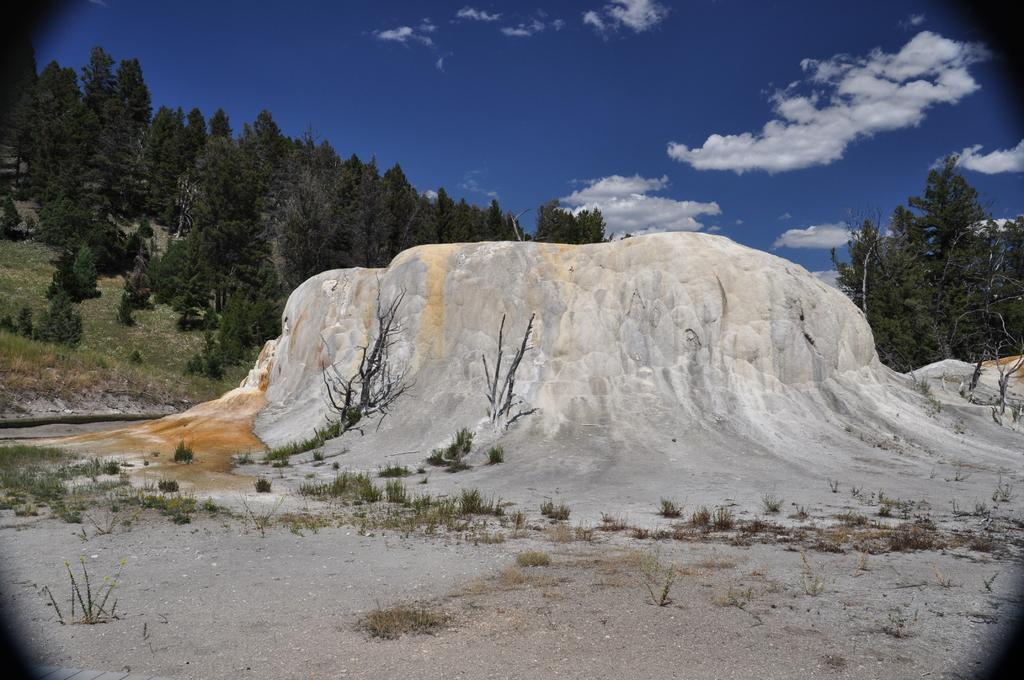Could you give a brief overview of what you see in this image? In this image, at the middle there is a white color mountain, we can see some green color trees, at the top there is a blue color sky and there are some white color clouds. 